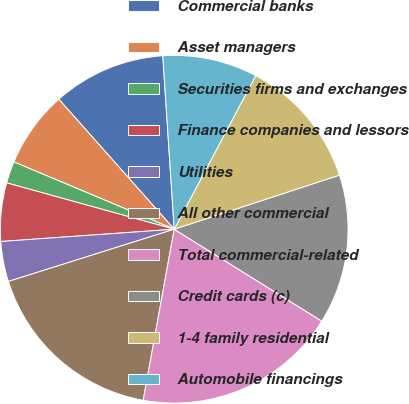Convert chart to OTSL. <chart><loc_0><loc_0><loc_500><loc_500><pie_chart><fcel>Commercial banks<fcel>Asset managers<fcel>Securities firms and exchanges<fcel>Finance companies and lessors<fcel>Utilities<fcel>All other commercial<fcel>Total commercial-related<fcel>Credit cards (c)<fcel>1-4 family residential<fcel>Automobile financings<nl><fcel>10.51%<fcel>7.12%<fcel>2.03%<fcel>5.42%<fcel>3.73%<fcel>17.29%<fcel>18.99%<fcel>13.9%<fcel>12.2%<fcel>8.81%<nl></chart> 